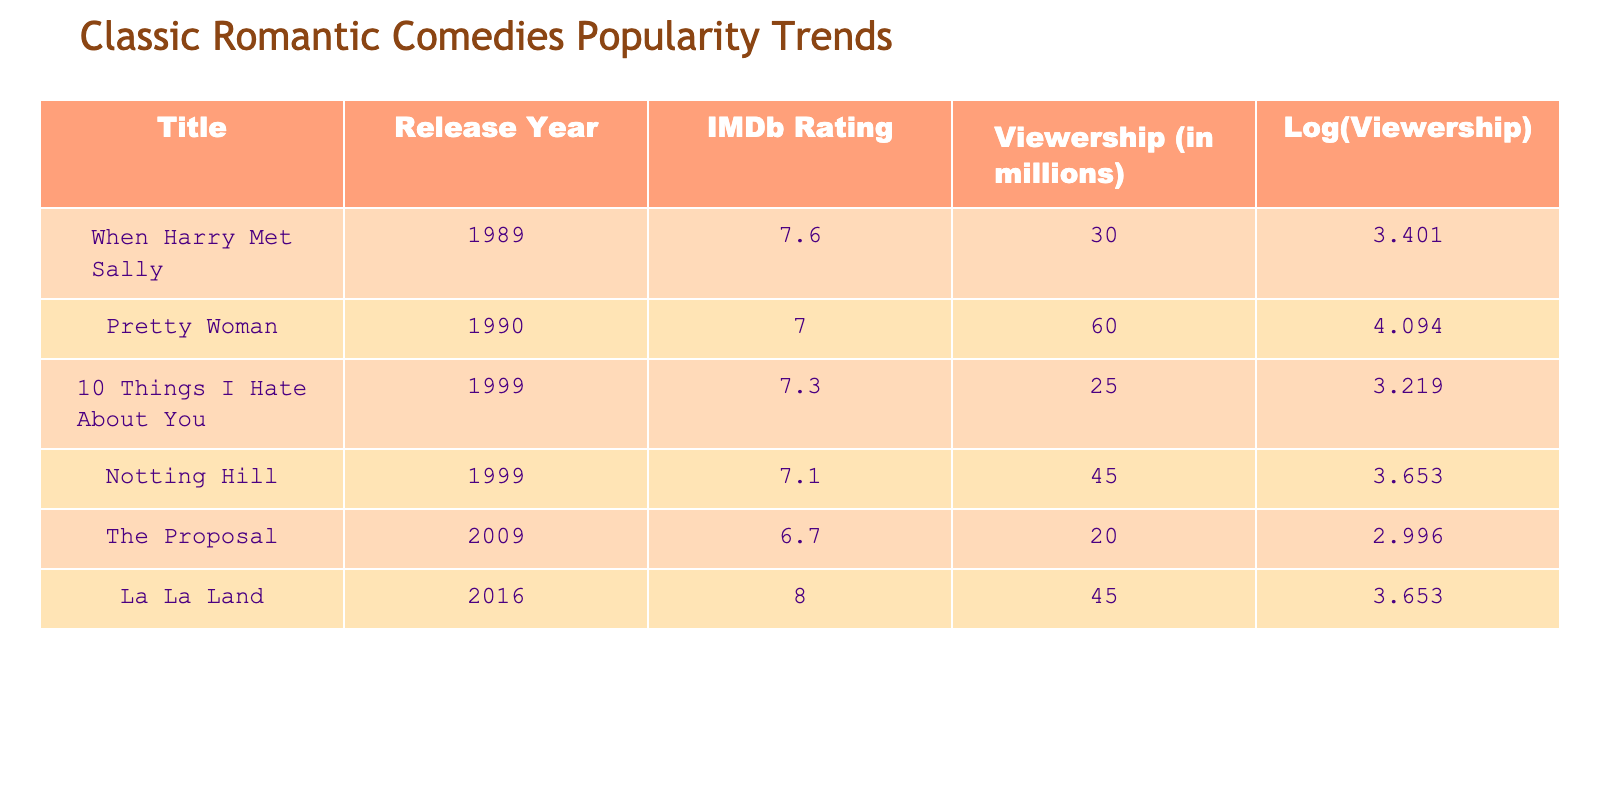What is the IMDb rating for "Notting Hill"? The IMDb rating for "Notting Hill" is found directly in the table under the "IMDb Rating" column next to its title, which shows a value of 7.1.
Answer: 7.1 Which movie had the highest viewership? Looking at the "Viewership" column, "Pretty Woman" has the highest viewership with a value of 60 million.
Answer: Pretty Woman What is the average IMDb rating of the movies listed? To calculate the average IMDb rating, sum all the ratings: (7.6 + 7.0 + 7.3 + 7.1 + 6.7 + 8.0) = 43.7. Then divide by the total number of movies, which is 6: 43.7/6 = 7.28333. Rounding gives an average of 7.3.
Answer: 7.3 Is "La La Land" more popular than "The Proposal"? By comparing their viewership numbers, "La La Land" has 45 million while "The Proposal" has 20 million, indicating that "La La Land" is more popular.
Answer: Yes What is the difference in viewership between "When Harry Met Sally" and "10 Things I Hate About You"? The viewership for "When Harry Met Sally" is 30 million and for "10 Things I Hate About You" it is 25 million. The difference is calculated as 30 - 25 = 5 million.
Answer: 5 million How many movies have an IMDb rating of 7 or higher? To find out, we count the movies with ratings 7 or higher: "When Harry Met Sally" (7.6), "Pretty Woman" (7.0), "10 Things I Hate About You" (7.3), "Notting Hill" (7.1), and "La La Land" (8.0). That gives us a total of 5 movies.
Answer: 5 Which movie has the same viewership as "Notting Hill"? The viewership for "Notting Hill" is 45 million, and by scanning the "Viewership" column, we find that "La La Land" also has a viewership of 45 million, thus they share the same viewership figure.
Answer: La La Land What is the total viewership of all the movies listed? To find the total viewership, we sum all the values in the "Viewership" column: 30 + 60 + 25 + 45 + 20 + 45 = 225 million.
Answer: 225 million Does "The Proposal" have a lower IMDb rating than "10 Things I Hate About You"? "The Proposal" has an IMDb rating of 6.7, while "10 Things I Hate About You" has 7.3. Since 6.7 is less than 7.3, the statement is true.
Answer: Yes 